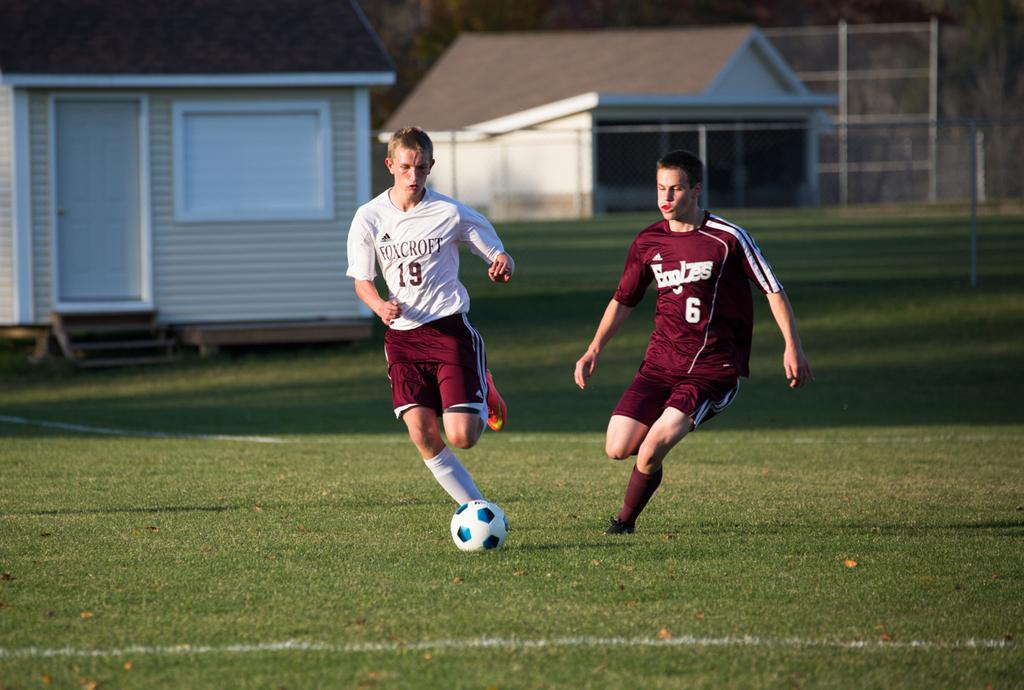How many people are playing football in the image? There are two men in the image playing a football game. What is the setting of the football game? The football game is being played in a location with houses and trees in the background, and grass at the bottom of the image. What type of arithmetic problem can be solved using the feet of the men in the image? There is no arithmetic problem or mention of feet in the image; it features two men playing football. 